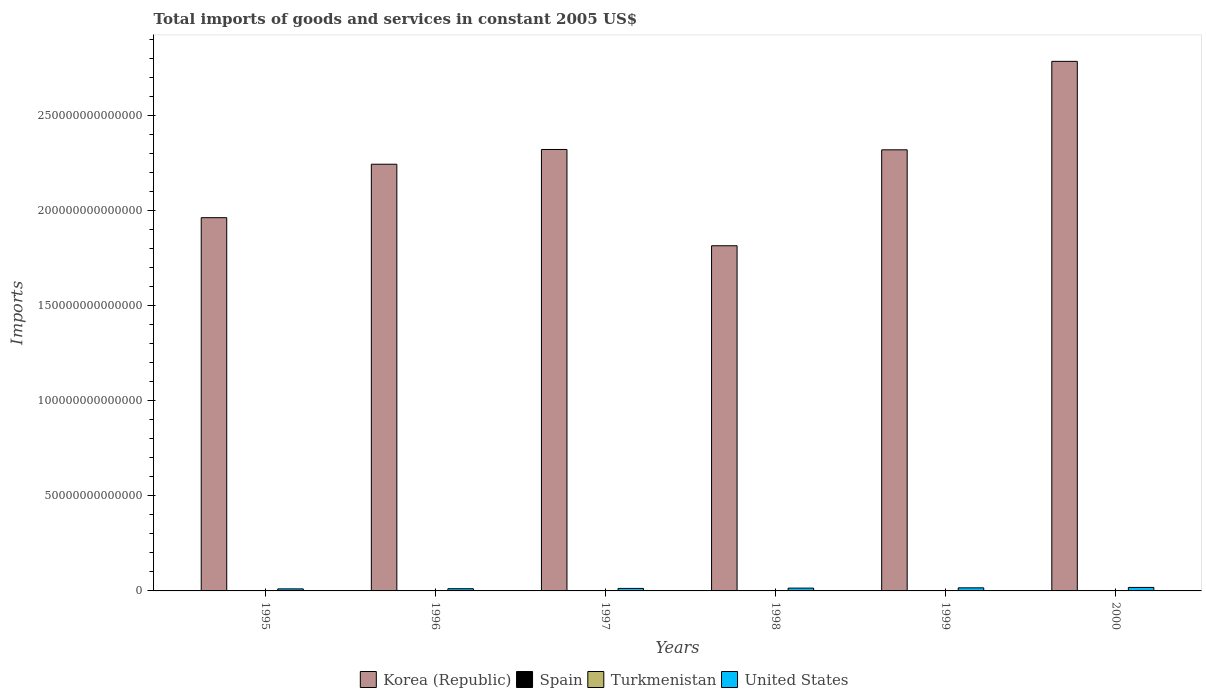How many different coloured bars are there?
Offer a terse response. 4. How many groups of bars are there?
Your answer should be compact. 6. How many bars are there on the 6th tick from the left?
Offer a very short reply. 4. In how many cases, is the number of bars for a given year not equal to the number of legend labels?
Keep it short and to the point. 0. What is the total imports of goods and services in Turkmenistan in 1997?
Your response must be concise. 3.58e+09. Across all years, what is the maximum total imports of goods and services in Spain?
Ensure brevity in your answer.  2.24e+11. Across all years, what is the minimum total imports of goods and services in Korea (Republic)?
Your answer should be very brief. 1.82e+14. In which year was the total imports of goods and services in United States maximum?
Your answer should be compact. 2000. What is the total total imports of goods and services in Turkmenistan in the graph?
Make the answer very short. 2.52e+1. What is the difference between the total imports of goods and services in Turkmenistan in 1995 and that in 1999?
Keep it short and to the point. 9.38e+07. What is the difference between the total imports of goods and services in Korea (Republic) in 1997 and the total imports of goods and services in Spain in 1999?
Give a very brief answer. 2.32e+14. What is the average total imports of goods and services in Spain per year?
Provide a succinct answer. 1.72e+11. In the year 1999, what is the difference between the total imports of goods and services in Turkmenistan and total imports of goods and services in United States?
Offer a very short reply. -1.62e+12. In how many years, is the total imports of goods and services in Turkmenistan greater than 210000000000000 US$?
Give a very brief answer. 0. What is the ratio of the total imports of goods and services in United States in 1997 to that in 2000?
Make the answer very short. 0.72. What is the difference between the highest and the second highest total imports of goods and services in Spain?
Keep it short and to the point. 1.94e+1. What is the difference between the highest and the lowest total imports of goods and services in Korea (Republic)?
Your answer should be very brief. 9.70e+13. Is the sum of the total imports of goods and services in Spain in 1997 and 2000 greater than the maximum total imports of goods and services in Turkmenistan across all years?
Offer a terse response. Yes. Is it the case that in every year, the sum of the total imports of goods and services in Korea (Republic) and total imports of goods and services in Spain is greater than the sum of total imports of goods and services in Turkmenistan and total imports of goods and services in United States?
Your response must be concise. Yes. What does the 2nd bar from the right in 1999 represents?
Give a very brief answer. Turkmenistan. How many years are there in the graph?
Offer a very short reply. 6. What is the difference between two consecutive major ticks on the Y-axis?
Provide a succinct answer. 5.00e+13. Does the graph contain any zero values?
Keep it short and to the point. No. Does the graph contain grids?
Your answer should be very brief. No. How are the legend labels stacked?
Provide a short and direct response. Horizontal. What is the title of the graph?
Offer a terse response. Total imports of goods and services in constant 2005 US$. Does "Lower middle income" appear as one of the legend labels in the graph?
Your answer should be very brief. No. What is the label or title of the Y-axis?
Offer a terse response. Imports. What is the Imports of Korea (Republic) in 1995?
Ensure brevity in your answer.  1.96e+14. What is the Imports of Spain in 1995?
Keep it short and to the point. 1.30e+11. What is the Imports of Turkmenistan in 1995?
Your response must be concise. 4.46e+09. What is the Imports of United States in 1995?
Provide a succinct answer. 1.07e+12. What is the Imports of Korea (Republic) in 1996?
Your answer should be compact. 2.24e+14. What is the Imports in Spain in 1996?
Your response must be concise. 1.39e+11. What is the Imports in Turkmenistan in 1996?
Offer a terse response. 3.83e+09. What is the Imports of United States in 1996?
Your response must be concise. 1.16e+12. What is the Imports of Korea (Republic) in 1997?
Your answer should be compact. 2.32e+14. What is the Imports of Spain in 1997?
Give a very brief answer. 1.57e+11. What is the Imports in Turkmenistan in 1997?
Provide a succinct answer. 3.58e+09. What is the Imports in United States in 1997?
Make the answer very short. 1.32e+12. What is the Imports of Korea (Republic) in 1998?
Make the answer very short. 1.82e+14. What is the Imports of Spain in 1998?
Provide a succinct answer. 1.80e+11. What is the Imports of Turkmenistan in 1998?
Make the answer very short. 3.93e+09. What is the Imports of United States in 1998?
Offer a very short reply. 1.48e+12. What is the Imports of Korea (Republic) in 1999?
Your answer should be very brief. 2.32e+14. What is the Imports in Spain in 1999?
Give a very brief answer. 2.05e+11. What is the Imports in Turkmenistan in 1999?
Offer a very short reply. 4.36e+09. What is the Imports of United States in 1999?
Provide a short and direct response. 1.63e+12. What is the Imports in Korea (Republic) in 2000?
Keep it short and to the point. 2.78e+14. What is the Imports of Spain in 2000?
Offer a terse response. 2.24e+11. What is the Imports of Turkmenistan in 2000?
Keep it short and to the point. 5.01e+09. What is the Imports in United States in 2000?
Keep it short and to the point. 1.84e+12. Across all years, what is the maximum Imports in Korea (Republic)?
Ensure brevity in your answer.  2.78e+14. Across all years, what is the maximum Imports in Spain?
Your answer should be compact. 2.24e+11. Across all years, what is the maximum Imports in Turkmenistan?
Offer a terse response. 5.01e+09. Across all years, what is the maximum Imports in United States?
Offer a terse response. 1.84e+12. Across all years, what is the minimum Imports in Korea (Republic)?
Give a very brief answer. 1.82e+14. Across all years, what is the minimum Imports of Spain?
Keep it short and to the point. 1.30e+11. Across all years, what is the minimum Imports in Turkmenistan?
Your response must be concise. 3.58e+09. Across all years, what is the minimum Imports in United States?
Provide a short and direct response. 1.07e+12. What is the total Imports in Korea (Republic) in the graph?
Your answer should be compact. 1.34e+15. What is the total Imports of Spain in the graph?
Give a very brief answer. 1.03e+12. What is the total Imports of Turkmenistan in the graph?
Offer a terse response. 2.52e+1. What is the total Imports of United States in the graph?
Keep it short and to the point. 8.49e+12. What is the difference between the Imports of Korea (Republic) in 1995 and that in 1996?
Your answer should be very brief. -2.81e+13. What is the difference between the Imports of Spain in 1995 and that in 1996?
Your answer should be compact. -9.61e+09. What is the difference between the Imports of Turkmenistan in 1995 and that in 1996?
Give a very brief answer. 6.31e+08. What is the difference between the Imports in United States in 1995 and that in 1996?
Give a very brief answer. -9.32e+1. What is the difference between the Imports in Korea (Republic) in 1995 and that in 1997?
Provide a succinct answer. -3.59e+13. What is the difference between the Imports of Spain in 1995 and that in 1997?
Give a very brief answer. -2.76e+1. What is the difference between the Imports in Turkmenistan in 1995 and that in 1997?
Your answer should be compact. 8.76e+08. What is the difference between the Imports of United States in 1995 and that in 1997?
Ensure brevity in your answer.  -2.50e+11. What is the difference between the Imports of Korea (Republic) in 1995 and that in 1998?
Keep it short and to the point. 1.48e+13. What is the difference between the Imports in Spain in 1995 and that in 1998?
Your answer should be very brief. -4.98e+1. What is the difference between the Imports in Turkmenistan in 1995 and that in 1998?
Give a very brief answer. 5.23e+08. What is the difference between the Imports in United States in 1995 and that in 1998?
Your answer should be very brief. -4.04e+11. What is the difference between the Imports in Korea (Republic) in 1995 and that in 1999?
Your response must be concise. -3.57e+13. What is the difference between the Imports in Spain in 1995 and that in 1999?
Your answer should be compact. -7.47e+1. What is the difference between the Imports of Turkmenistan in 1995 and that in 1999?
Offer a terse response. 9.38e+07. What is the difference between the Imports in United States in 1995 and that in 1999?
Give a very brief answer. -5.54e+11. What is the difference between the Imports of Korea (Republic) in 1995 and that in 2000?
Give a very brief answer. -8.22e+13. What is the difference between the Imports in Spain in 1995 and that in 2000?
Your answer should be very brief. -9.41e+1. What is the difference between the Imports in Turkmenistan in 1995 and that in 2000?
Ensure brevity in your answer.  -5.56e+08. What is the difference between the Imports of United States in 1995 and that in 2000?
Provide a short and direct response. -7.66e+11. What is the difference between the Imports in Korea (Republic) in 1996 and that in 1997?
Give a very brief answer. -7.76e+12. What is the difference between the Imports of Spain in 1996 and that in 1997?
Keep it short and to the point. -1.80e+1. What is the difference between the Imports of Turkmenistan in 1996 and that in 1997?
Offer a terse response. 2.45e+08. What is the difference between the Imports of United States in 1996 and that in 1997?
Give a very brief answer. -1.57e+11. What is the difference between the Imports of Korea (Republic) in 1996 and that in 1998?
Offer a terse response. 4.29e+13. What is the difference between the Imports in Spain in 1996 and that in 1998?
Keep it short and to the point. -4.02e+1. What is the difference between the Imports of Turkmenistan in 1996 and that in 1998?
Offer a terse response. -1.08e+08. What is the difference between the Imports in United States in 1996 and that in 1998?
Provide a short and direct response. -3.11e+11. What is the difference between the Imports of Korea (Republic) in 1996 and that in 1999?
Offer a terse response. -7.58e+12. What is the difference between the Imports in Spain in 1996 and that in 1999?
Offer a very short reply. -6.51e+1. What is the difference between the Imports of Turkmenistan in 1996 and that in 1999?
Provide a succinct answer. -5.37e+08. What is the difference between the Imports in United States in 1996 and that in 1999?
Provide a succinct answer. -4.61e+11. What is the difference between the Imports in Korea (Republic) in 1996 and that in 2000?
Make the answer very short. -5.41e+13. What is the difference between the Imports in Spain in 1996 and that in 2000?
Give a very brief answer. -8.45e+1. What is the difference between the Imports in Turkmenistan in 1996 and that in 2000?
Your answer should be very brief. -1.19e+09. What is the difference between the Imports of United States in 1996 and that in 2000?
Your answer should be compact. -6.72e+11. What is the difference between the Imports in Korea (Republic) in 1997 and that in 1998?
Offer a very short reply. 5.06e+13. What is the difference between the Imports of Spain in 1997 and that in 1998?
Your response must be concise. -2.22e+1. What is the difference between the Imports in Turkmenistan in 1997 and that in 1998?
Offer a terse response. -3.53e+08. What is the difference between the Imports of United States in 1997 and that in 1998?
Provide a succinct answer. -1.54e+11. What is the difference between the Imports in Korea (Republic) in 1997 and that in 1999?
Make the answer very short. 1.82e+11. What is the difference between the Imports of Spain in 1997 and that in 1999?
Your answer should be compact. -4.71e+1. What is the difference between the Imports of Turkmenistan in 1997 and that in 1999?
Give a very brief answer. -7.82e+08. What is the difference between the Imports in United States in 1997 and that in 1999?
Ensure brevity in your answer.  -3.04e+11. What is the difference between the Imports of Korea (Republic) in 1997 and that in 2000?
Your response must be concise. -4.63e+13. What is the difference between the Imports of Spain in 1997 and that in 2000?
Your response must be concise. -6.66e+1. What is the difference between the Imports in Turkmenistan in 1997 and that in 2000?
Provide a short and direct response. -1.43e+09. What is the difference between the Imports of United States in 1997 and that in 2000?
Your answer should be compact. -5.16e+11. What is the difference between the Imports in Korea (Republic) in 1998 and that in 1999?
Provide a short and direct response. -5.05e+13. What is the difference between the Imports of Spain in 1998 and that in 1999?
Keep it short and to the point. -2.49e+1. What is the difference between the Imports of Turkmenistan in 1998 and that in 1999?
Ensure brevity in your answer.  -4.29e+08. What is the difference between the Imports of United States in 1998 and that in 1999?
Ensure brevity in your answer.  -1.50e+11. What is the difference between the Imports in Korea (Republic) in 1998 and that in 2000?
Make the answer very short. -9.70e+13. What is the difference between the Imports of Spain in 1998 and that in 2000?
Provide a succinct answer. -4.44e+1. What is the difference between the Imports of Turkmenistan in 1998 and that in 2000?
Provide a short and direct response. -1.08e+09. What is the difference between the Imports in United States in 1998 and that in 2000?
Ensure brevity in your answer.  -3.61e+11. What is the difference between the Imports in Korea (Republic) in 1999 and that in 2000?
Give a very brief answer. -4.65e+13. What is the difference between the Imports of Spain in 1999 and that in 2000?
Provide a short and direct response. -1.94e+1. What is the difference between the Imports of Turkmenistan in 1999 and that in 2000?
Keep it short and to the point. -6.50e+08. What is the difference between the Imports in United States in 1999 and that in 2000?
Offer a terse response. -2.12e+11. What is the difference between the Imports of Korea (Republic) in 1995 and the Imports of Spain in 1996?
Give a very brief answer. 1.96e+14. What is the difference between the Imports of Korea (Republic) in 1995 and the Imports of Turkmenistan in 1996?
Make the answer very short. 1.96e+14. What is the difference between the Imports of Korea (Republic) in 1995 and the Imports of United States in 1996?
Make the answer very short. 1.95e+14. What is the difference between the Imports in Spain in 1995 and the Imports in Turkmenistan in 1996?
Provide a short and direct response. 1.26e+11. What is the difference between the Imports in Spain in 1995 and the Imports in United States in 1996?
Make the answer very short. -1.03e+12. What is the difference between the Imports of Turkmenistan in 1995 and the Imports of United States in 1996?
Make the answer very short. -1.16e+12. What is the difference between the Imports in Korea (Republic) in 1995 and the Imports in Spain in 1997?
Your answer should be very brief. 1.96e+14. What is the difference between the Imports of Korea (Republic) in 1995 and the Imports of Turkmenistan in 1997?
Provide a short and direct response. 1.96e+14. What is the difference between the Imports in Korea (Republic) in 1995 and the Imports in United States in 1997?
Your response must be concise. 1.95e+14. What is the difference between the Imports of Spain in 1995 and the Imports of Turkmenistan in 1997?
Provide a succinct answer. 1.26e+11. What is the difference between the Imports in Spain in 1995 and the Imports in United States in 1997?
Ensure brevity in your answer.  -1.19e+12. What is the difference between the Imports of Turkmenistan in 1995 and the Imports of United States in 1997?
Ensure brevity in your answer.  -1.32e+12. What is the difference between the Imports of Korea (Republic) in 1995 and the Imports of Spain in 1998?
Offer a terse response. 1.96e+14. What is the difference between the Imports in Korea (Republic) in 1995 and the Imports in Turkmenistan in 1998?
Your answer should be compact. 1.96e+14. What is the difference between the Imports in Korea (Republic) in 1995 and the Imports in United States in 1998?
Provide a succinct answer. 1.95e+14. What is the difference between the Imports in Spain in 1995 and the Imports in Turkmenistan in 1998?
Your answer should be compact. 1.26e+11. What is the difference between the Imports of Spain in 1995 and the Imports of United States in 1998?
Keep it short and to the point. -1.35e+12. What is the difference between the Imports in Turkmenistan in 1995 and the Imports in United States in 1998?
Your answer should be compact. -1.47e+12. What is the difference between the Imports in Korea (Republic) in 1995 and the Imports in Spain in 1999?
Give a very brief answer. 1.96e+14. What is the difference between the Imports in Korea (Republic) in 1995 and the Imports in Turkmenistan in 1999?
Your answer should be very brief. 1.96e+14. What is the difference between the Imports in Korea (Republic) in 1995 and the Imports in United States in 1999?
Ensure brevity in your answer.  1.95e+14. What is the difference between the Imports in Spain in 1995 and the Imports in Turkmenistan in 1999?
Ensure brevity in your answer.  1.25e+11. What is the difference between the Imports of Spain in 1995 and the Imports of United States in 1999?
Offer a terse response. -1.50e+12. What is the difference between the Imports of Turkmenistan in 1995 and the Imports of United States in 1999?
Provide a short and direct response. -1.62e+12. What is the difference between the Imports of Korea (Republic) in 1995 and the Imports of Spain in 2000?
Give a very brief answer. 1.96e+14. What is the difference between the Imports in Korea (Republic) in 1995 and the Imports in Turkmenistan in 2000?
Make the answer very short. 1.96e+14. What is the difference between the Imports in Korea (Republic) in 1995 and the Imports in United States in 2000?
Keep it short and to the point. 1.94e+14. What is the difference between the Imports of Spain in 1995 and the Imports of Turkmenistan in 2000?
Offer a terse response. 1.25e+11. What is the difference between the Imports of Spain in 1995 and the Imports of United States in 2000?
Your answer should be compact. -1.71e+12. What is the difference between the Imports in Turkmenistan in 1995 and the Imports in United States in 2000?
Offer a terse response. -1.83e+12. What is the difference between the Imports in Korea (Republic) in 1996 and the Imports in Spain in 1997?
Make the answer very short. 2.24e+14. What is the difference between the Imports of Korea (Republic) in 1996 and the Imports of Turkmenistan in 1997?
Offer a terse response. 2.24e+14. What is the difference between the Imports in Korea (Republic) in 1996 and the Imports in United States in 1997?
Make the answer very short. 2.23e+14. What is the difference between the Imports of Spain in 1996 and the Imports of Turkmenistan in 1997?
Your answer should be very brief. 1.36e+11. What is the difference between the Imports in Spain in 1996 and the Imports in United States in 1997?
Give a very brief answer. -1.18e+12. What is the difference between the Imports of Turkmenistan in 1996 and the Imports of United States in 1997?
Your answer should be compact. -1.32e+12. What is the difference between the Imports of Korea (Republic) in 1996 and the Imports of Spain in 1998?
Your response must be concise. 2.24e+14. What is the difference between the Imports of Korea (Republic) in 1996 and the Imports of Turkmenistan in 1998?
Keep it short and to the point. 2.24e+14. What is the difference between the Imports in Korea (Republic) in 1996 and the Imports in United States in 1998?
Ensure brevity in your answer.  2.23e+14. What is the difference between the Imports of Spain in 1996 and the Imports of Turkmenistan in 1998?
Provide a short and direct response. 1.35e+11. What is the difference between the Imports of Spain in 1996 and the Imports of United States in 1998?
Offer a very short reply. -1.34e+12. What is the difference between the Imports of Turkmenistan in 1996 and the Imports of United States in 1998?
Make the answer very short. -1.47e+12. What is the difference between the Imports of Korea (Republic) in 1996 and the Imports of Spain in 1999?
Give a very brief answer. 2.24e+14. What is the difference between the Imports in Korea (Republic) in 1996 and the Imports in Turkmenistan in 1999?
Keep it short and to the point. 2.24e+14. What is the difference between the Imports in Korea (Republic) in 1996 and the Imports in United States in 1999?
Your answer should be very brief. 2.23e+14. What is the difference between the Imports of Spain in 1996 and the Imports of Turkmenistan in 1999?
Offer a very short reply. 1.35e+11. What is the difference between the Imports in Spain in 1996 and the Imports in United States in 1999?
Provide a succinct answer. -1.49e+12. What is the difference between the Imports in Turkmenistan in 1996 and the Imports in United States in 1999?
Your response must be concise. -1.62e+12. What is the difference between the Imports in Korea (Republic) in 1996 and the Imports in Spain in 2000?
Give a very brief answer. 2.24e+14. What is the difference between the Imports in Korea (Republic) in 1996 and the Imports in Turkmenistan in 2000?
Offer a very short reply. 2.24e+14. What is the difference between the Imports of Korea (Republic) in 1996 and the Imports of United States in 2000?
Make the answer very short. 2.23e+14. What is the difference between the Imports of Spain in 1996 and the Imports of Turkmenistan in 2000?
Ensure brevity in your answer.  1.34e+11. What is the difference between the Imports of Spain in 1996 and the Imports of United States in 2000?
Ensure brevity in your answer.  -1.70e+12. What is the difference between the Imports of Turkmenistan in 1996 and the Imports of United States in 2000?
Your response must be concise. -1.83e+12. What is the difference between the Imports of Korea (Republic) in 1997 and the Imports of Spain in 1998?
Your response must be concise. 2.32e+14. What is the difference between the Imports in Korea (Republic) in 1997 and the Imports in Turkmenistan in 1998?
Your answer should be compact. 2.32e+14. What is the difference between the Imports of Korea (Republic) in 1997 and the Imports of United States in 1998?
Ensure brevity in your answer.  2.31e+14. What is the difference between the Imports in Spain in 1997 and the Imports in Turkmenistan in 1998?
Your answer should be very brief. 1.53e+11. What is the difference between the Imports of Spain in 1997 and the Imports of United States in 1998?
Make the answer very short. -1.32e+12. What is the difference between the Imports in Turkmenistan in 1997 and the Imports in United States in 1998?
Your answer should be very brief. -1.47e+12. What is the difference between the Imports in Korea (Republic) in 1997 and the Imports in Spain in 1999?
Provide a short and direct response. 2.32e+14. What is the difference between the Imports in Korea (Republic) in 1997 and the Imports in Turkmenistan in 1999?
Give a very brief answer. 2.32e+14. What is the difference between the Imports in Korea (Republic) in 1997 and the Imports in United States in 1999?
Offer a very short reply. 2.31e+14. What is the difference between the Imports of Spain in 1997 and the Imports of Turkmenistan in 1999?
Offer a terse response. 1.53e+11. What is the difference between the Imports in Spain in 1997 and the Imports in United States in 1999?
Offer a terse response. -1.47e+12. What is the difference between the Imports in Turkmenistan in 1997 and the Imports in United States in 1999?
Offer a very short reply. -1.62e+12. What is the difference between the Imports in Korea (Republic) in 1997 and the Imports in Spain in 2000?
Your answer should be very brief. 2.32e+14. What is the difference between the Imports of Korea (Republic) in 1997 and the Imports of Turkmenistan in 2000?
Your answer should be very brief. 2.32e+14. What is the difference between the Imports in Korea (Republic) in 1997 and the Imports in United States in 2000?
Your response must be concise. 2.30e+14. What is the difference between the Imports in Spain in 1997 and the Imports in Turkmenistan in 2000?
Ensure brevity in your answer.  1.52e+11. What is the difference between the Imports in Spain in 1997 and the Imports in United States in 2000?
Offer a very short reply. -1.68e+12. What is the difference between the Imports of Turkmenistan in 1997 and the Imports of United States in 2000?
Make the answer very short. -1.83e+12. What is the difference between the Imports in Korea (Republic) in 1998 and the Imports in Spain in 1999?
Ensure brevity in your answer.  1.81e+14. What is the difference between the Imports of Korea (Republic) in 1998 and the Imports of Turkmenistan in 1999?
Your answer should be very brief. 1.81e+14. What is the difference between the Imports in Korea (Republic) in 1998 and the Imports in United States in 1999?
Your answer should be very brief. 1.80e+14. What is the difference between the Imports of Spain in 1998 and the Imports of Turkmenistan in 1999?
Give a very brief answer. 1.75e+11. What is the difference between the Imports in Spain in 1998 and the Imports in United States in 1999?
Your response must be concise. -1.45e+12. What is the difference between the Imports of Turkmenistan in 1998 and the Imports of United States in 1999?
Your answer should be very brief. -1.62e+12. What is the difference between the Imports in Korea (Republic) in 1998 and the Imports in Spain in 2000?
Keep it short and to the point. 1.81e+14. What is the difference between the Imports in Korea (Republic) in 1998 and the Imports in Turkmenistan in 2000?
Offer a terse response. 1.81e+14. What is the difference between the Imports in Korea (Republic) in 1998 and the Imports in United States in 2000?
Ensure brevity in your answer.  1.80e+14. What is the difference between the Imports in Spain in 1998 and the Imports in Turkmenistan in 2000?
Your answer should be compact. 1.75e+11. What is the difference between the Imports of Spain in 1998 and the Imports of United States in 2000?
Your answer should be very brief. -1.66e+12. What is the difference between the Imports in Turkmenistan in 1998 and the Imports in United States in 2000?
Make the answer very short. -1.83e+12. What is the difference between the Imports of Korea (Republic) in 1999 and the Imports of Spain in 2000?
Your answer should be very brief. 2.32e+14. What is the difference between the Imports in Korea (Republic) in 1999 and the Imports in Turkmenistan in 2000?
Your answer should be compact. 2.32e+14. What is the difference between the Imports of Korea (Republic) in 1999 and the Imports of United States in 2000?
Give a very brief answer. 2.30e+14. What is the difference between the Imports of Spain in 1999 and the Imports of Turkmenistan in 2000?
Ensure brevity in your answer.  2.00e+11. What is the difference between the Imports in Spain in 1999 and the Imports in United States in 2000?
Give a very brief answer. -1.63e+12. What is the difference between the Imports of Turkmenistan in 1999 and the Imports of United States in 2000?
Offer a very short reply. -1.83e+12. What is the average Imports in Korea (Republic) per year?
Your answer should be very brief. 2.24e+14. What is the average Imports of Spain per year?
Make the answer very short. 1.72e+11. What is the average Imports of Turkmenistan per year?
Offer a very short reply. 4.20e+09. What is the average Imports in United States per year?
Provide a succinct answer. 1.42e+12. In the year 1995, what is the difference between the Imports of Korea (Republic) and Imports of Spain?
Provide a short and direct response. 1.96e+14. In the year 1995, what is the difference between the Imports in Korea (Republic) and Imports in Turkmenistan?
Make the answer very short. 1.96e+14. In the year 1995, what is the difference between the Imports in Korea (Republic) and Imports in United States?
Ensure brevity in your answer.  1.95e+14. In the year 1995, what is the difference between the Imports in Spain and Imports in Turkmenistan?
Ensure brevity in your answer.  1.25e+11. In the year 1995, what is the difference between the Imports of Spain and Imports of United States?
Offer a terse response. -9.41e+11. In the year 1995, what is the difference between the Imports of Turkmenistan and Imports of United States?
Offer a terse response. -1.07e+12. In the year 1996, what is the difference between the Imports of Korea (Republic) and Imports of Spain?
Keep it short and to the point. 2.24e+14. In the year 1996, what is the difference between the Imports of Korea (Republic) and Imports of Turkmenistan?
Ensure brevity in your answer.  2.24e+14. In the year 1996, what is the difference between the Imports of Korea (Republic) and Imports of United States?
Offer a terse response. 2.23e+14. In the year 1996, what is the difference between the Imports in Spain and Imports in Turkmenistan?
Your answer should be very brief. 1.36e+11. In the year 1996, what is the difference between the Imports in Spain and Imports in United States?
Offer a very short reply. -1.03e+12. In the year 1996, what is the difference between the Imports of Turkmenistan and Imports of United States?
Provide a succinct answer. -1.16e+12. In the year 1997, what is the difference between the Imports in Korea (Republic) and Imports in Spain?
Offer a terse response. 2.32e+14. In the year 1997, what is the difference between the Imports in Korea (Republic) and Imports in Turkmenistan?
Offer a very short reply. 2.32e+14. In the year 1997, what is the difference between the Imports of Korea (Republic) and Imports of United States?
Your response must be concise. 2.31e+14. In the year 1997, what is the difference between the Imports in Spain and Imports in Turkmenistan?
Your response must be concise. 1.54e+11. In the year 1997, what is the difference between the Imports in Spain and Imports in United States?
Give a very brief answer. -1.16e+12. In the year 1997, what is the difference between the Imports in Turkmenistan and Imports in United States?
Your answer should be very brief. -1.32e+12. In the year 1998, what is the difference between the Imports in Korea (Republic) and Imports in Spain?
Ensure brevity in your answer.  1.81e+14. In the year 1998, what is the difference between the Imports in Korea (Republic) and Imports in Turkmenistan?
Your answer should be compact. 1.81e+14. In the year 1998, what is the difference between the Imports of Korea (Republic) and Imports of United States?
Offer a very short reply. 1.80e+14. In the year 1998, what is the difference between the Imports of Spain and Imports of Turkmenistan?
Offer a very short reply. 1.76e+11. In the year 1998, what is the difference between the Imports in Spain and Imports in United States?
Make the answer very short. -1.30e+12. In the year 1998, what is the difference between the Imports in Turkmenistan and Imports in United States?
Make the answer very short. -1.47e+12. In the year 1999, what is the difference between the Imports in Korea (Republic) and Imports in Spain?
Your response must be concise. 2.32e+14. In the year 1999, what is the difference between the Imports in Korea (Republic) and Imports in Turkmenistan?
Your answer should be very brief. 2.32e+14. In the year 1999, what is the difference between the Imports in Korea (Republic) and Imports in United States?
Offer a very short reply. 2.30e+14. In the year 1999, what is the difference between the Imports in Spain and Imports in Turkmenistan?
Provide a succinct answer. 2.00e+11. In the year 1999, what is the difference between the Imports in Spain and Imports in United States?
Offer a terse response. -1.42e+12. In the year 1999, what is the difference between the Imports of Turkmenistan and Imports of United States?
Keep it short and to the point. -1.62e+12. In the year 2000, what is the difference between the Imports in Korea (Republic) and Imports in Spain?
Ensure brevity in your answer.  2.78e+14. In the year 2000, what is the difference between the Imports of Korea (Republic) and Imports of Turkmenistan?
Your answer should be very brief. 2.78e+14. In the year 2000, what is the difference between the Imports in Korea (Republic) and Imports in United States?
Provide a succinct answer. 2.77e+14. In the year 2000, what is the difference between the Imports in Spain and Imports in Turkmenistan?
Make the answer very short. 2.19e+11. In the year 2000, what is the difference between the Imports in Spain and Imports in United States?
Offer a very short reply. -1.61e+12. In the year 2000, what is the difference between the Imports in Turkmenistan and Imports in United States?
Your response must be concise. -1.83e+12. What is the ratio of the Imports in Korea (Republic) in 1995 to that in 1996?
Your response must be concise. 0.87. What is the ratio of the Imports in Spain in 1995 to that in 1996?
Keep it short and to the point. 0.93. What is the ratio of the Imports in Turkmenistan in 1995 to that in 1996?
Your answer should be compact. 1.17. What is the ratio of the Imports of Korea (Republic) in 1995 to that in 1997?
Your answer should be compact. 0.85. What is the ratio of the Imports of Spain in 1995 to that in 1997?
Provide a succinct answer. 0.82. What is the ratio of the Imports of Turkmenistan in 1995 to that in 1997?
Your answer should be very brief. 1.24. What is the ratio of the Imports of United States in 1995 to that in 1997?
Keep it short and to the point. 0.81. What is the ratio of the Imports in Korea (Republic) in 1995 to that in 1998?
Offer a very short reply. 1.08. What is the ratio of the Imports of Spain in 1995 to that in 1998?
Provide a short and direct response. 0.72. What is the ratio of the Imports in Turkmenistan in 1995 to that in 1998?
Provide a short and direct response. 1.13. What is the ratio of the Imports of United States in 1995 to that in 1998?
Offer a very short reply. 0.73. What is the ratio of the Imports in Korea (Republic) in 1995 to that in 1999?
Ensure brevity in your answer.  0.85. What is the ratio of the Imports in Spain in 1995 to that in 1999?
Your response must be concise. 0.63. What is the ratio of the Imports of Turkmenistan in 1995 to that in 1999?
Give a very brief answer. 1.02. What is the ratio of the Imports in United States in 1995 to that in 1999?
Provide a short and direct response. 0.66. What is the ratio of the Imports of Korea (Republic) in 1995 to that in 2000?
Give a very brief answer. 0.7. What is the ratio of the Imports of Spain in 1995 to that in 2000?
Provide a short and direct response. 0.58. What is the ratio of the Imports of Turkmenistan in 1995 to that in 2000?
Provide a succinct answer. 0.89. What is the ratio of the Imports of United States in 1995 to that in 2000?
Ensure brevity in your answer.  0.58. What is the ratio of the Imports of Korea (Republic) in 1996 to that in 1997?
Ensure brevity in your answer.  0.97. What is the ratio of the Imports in Spain in 1996 to that in 1997?
Ensure brevity in your answer.  0.89. What is the ratio of the Imports of Turkmenistan in 1996 to that in 1997?
Your response must be concise. 1.07. What is the ratio of the Imports of United States in 1996 to that in 1997?
Offer a very short reply. 0.88. What is the ratio of the Imports of Korea (Republic) in 1996 to that in 1998?
Offer a terse response. 1.24. What is the ratio of the Imports in Spain in 1996 to that in 1998?
Your response must be concise. 0.78. What is the ratio of the Imports in Turkmenistan in 1996 to that in 1998?
Your answer should be very brief. 0.97. What is the ratio of the Imports in United States in 1996 to that in 1998?
Your answer should be compact. 0.79. What is the ratio of the Imports in Korea (Republic) in 1996 to that in 1999?
Give a very brief answer. 0.97. What is the ratio of the Imports of Spain in 1996 to that in 1999?
Ensure brevity in your answer.  0.68. What is the ratio of the Imports of Turkmenistan in 1996 to that in 1999?
Ensure brevity in your answer.  0.88. What is the ratio of the Imports in United States in 1996 to that in 1999?
Ensure brevity in your answer.  0.72. What is the ratio of the Imports in Korea (Republic) in 1996 to that in 2000?
Your response must be concise. 0.81. What is the ratio of the Imports in Spain in 1996 to that in 2000?
Ensure brevity in your answer.  0.62. What is the ratio of the Imports in Turkmenistan in 1996 to that in 2000?
Provide a succinct answer. 0.76. What is the ratio of the Imports of United States in 1996 to that in 2000?
Offer a very short reply. 0.63. What is the ratio of the Imports of Korea (Republic) in 1997 to that in 1998?
Give a very brief answer. 1.28. What is the ratio of the Imports of Spain in 1997 to that in 1998?
Your response must be concise. 0.88. What is the ratio of the Imports of Turkmenistan in 1997 to that in 1998?
Your response must be concise. 0.91. What is the ratio of the Imports of United States in 1997 to that in 1998?
Your answer should be very brief. 0.9. What is the ratio of the Imports of Spain in 1997 to that in 1999?
Offer a terse response. 0.77. What is the ratio of the Imports in Turkmenistan in 1997 to that in 1999?
Keep it short and to the point. 0.82. What is the ratio of the Imports of United States in 1997 to that in 1999?
Give a very brief answer. 0.81. What is the ratio of the Imports in Korea (Republic) in 1997 to that in 2000?
Your response must be concise. 0.83. What is the ratio of the Imports of Spain in 1997 to that in 2000?
Your response must be concise. 0.7. What is the ratio of the Imports of Turkmenistan in 1997 to that in 2000?
Your answer should be compact. 0.71. What is the ratio of the Imports in United States in 1997 to that in 2000?
Your answer should be compact. 0.72. What is the ratio of the Imports in Korea (Republic) in 1998 to that in 1999?
Give a very brief answer. 0.78. What is the ratio of the Imports of Spain in 1998 to that in 1999?
Make the answer very short. 0.88. What is the ratio of the Imports in Turkmenistan in 1998 to that in 1999?
Your answer should be compact. 0.9. What is the ratio of the Imports in United States in 1998 to that in 1999?
Offer a terse response. 0.91. What is the ratio of the Imports of Korea (Republic) in 1998 to that in 2000?
Ensure brevity in your answer.  0.65. What is the ratio of the Imports of Spain in 1998 to that in 2000?
Offer a terse response. 0.8. What is the ratio of the Imports of Turkmenistan in 1998 to that in 2000?
Keep it short and to the point. 0.78. What is the ratio of the Imports of United States in 1998 to that in 2000?
Ensure brevity in your answer.  0.8. What is the ratio of the Imports in Korea (Republic) in 1999 to that in 2000?
Ensure brevity in your answer.  0.83. What is the ratio of the Imports in Spain in 1999 to that in 2000?
Keep it short and to the point. 0.91. What is the ratio of the Imports in Turkmenistan in 1999 to that in 2000?
Provide a short and direct response. 0.87. What is the ratio of the Imports of United States in 1999 to that in 2000?
Your response must be concise. 0.88. What is the difference between the highest and the second highest Imports of Korea (Republic)?
Ensure brevity in your answer.  4.63e+13. What is the difference between the highest and the second highest Imports in Spain?
Make the answer very short. 1.94e+1. What is the difference between the highest and the second highest Imports of Turkmenistan?
Your answer should be very brief. 5.56e+08. What is the difference between the highest and the second highest Imports of United States?
Ensure brevity in your answer.  2.12e+11. What is the difference between the highest and the lowest Imports of Korea (Republic)?
Your answer should be very brief. 9.70e+13. What is the difference between the highest and the lowest Imports in Spain?
Offer a terse response. 9.41e+1. What is the difference between the highest and the lowest Imports of Turkmenistan?
Ensure brevity in your answer.  1.43e+09. What is the difference between the highest and the lowest Imports of United States?
Provide a succinct answer. 7.66e+11. 